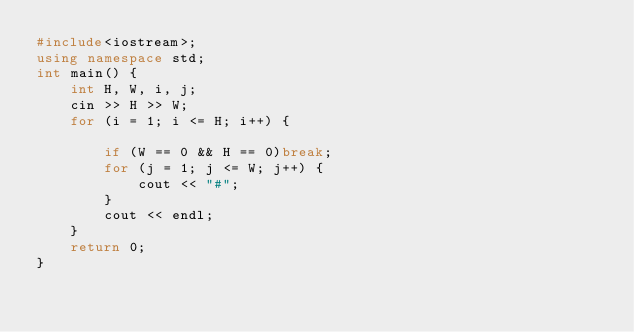<code> <loc_0><loc_0><loc_500><loc_500><_C++_>#include<iostream>;
using namespace std;
int main() {
	int H, W, i, j;
	cin >> H >> W;
	for (i = 1; i <= H; i++) {
	
		if (W == 0 && H == 0)break;
		for (j = 1; j <= W; j++) {
			cout << "#";
		}
		cout << endl;
	}
	return 0;
}</code> 